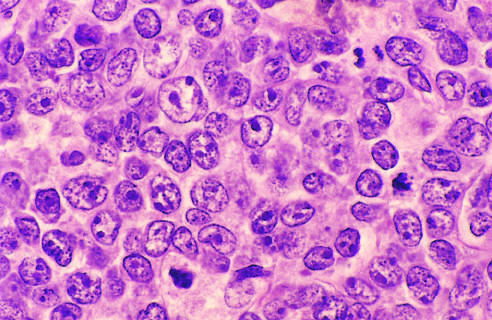what do the tumor cells have?
Answer the question using a single word or phrase. Large nuclei with open chromatin and prominent nucleoli 